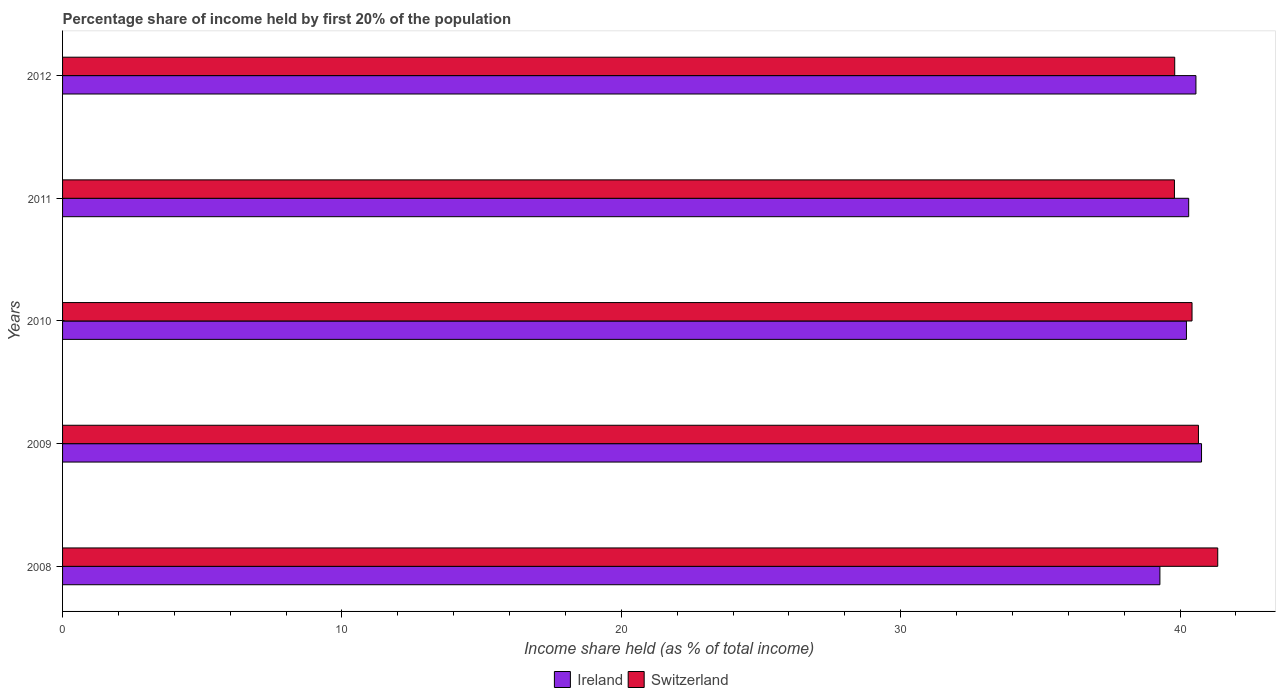How many groups of bars are there?
Provide a short and direct response. 5. Are the number of bars on each tick of the Y-axis equal?
Make the answer very short. Yes. How many bars are there on the 3rd tick from the top?
Provide a succinct answer. 2. How many bars are there on the 2nd tick from the bottom?
Your response must be concise. 2. What is the label of the 2nd group of bars from the top?
Provide a short and direct response. 2011. In how many cases, is the number of bars for a given year not equal to the number of legend labels?
Offer a very short reply. 0. What is the share of income held by first 20% of the population in Switzerland in 2012?
Keep it short and to the point. 39.81. Across all years, what is the maximum share of income held by first 20% of the population in Ireland?
Your answer should be very brief. 40.77. Across all years, what is the minimum share of income held by first 20% of the population in Ireland?
Offer a very short reply. 39.28. What is the total share of income held by first 20% of the population in Switzerland in the graph?
Your answer should be compact. 202.05. What is the difference between the share of income held by first 20% of the population in Switzerland in 2010 and that in 2012?
Offer a terse response. 0.62. What is the average share of income held by first 20% of the population in Ireland per year?
Provide a short and direct response. 40.23. In the year 2010, what is the difference between the share of income held by first 20% of the population in Switzerland and share of income held by first 20% of the population in Ireland?
Ensure brevity in your answer.  0.2. In how many years, is the share of income held by first 20% of the population in Ireland greater than 26 %?
Your answer should be very brief. 5. What is the ratio of the share of income held by first 20% of the population in Switzerland in 2008 to that in 2011?
Your response must be concise. 1.04. Is the share of income held by first 20% of the population in Ireland in 2011 less than that in 2012?
Keep it short and to the point. Yes. Is the difference between the share of income held by first 20% of the population in Switzerland in 2008 and 2010 greater than the difference between the share of income held by first 20% of the population in Ireland in 2008 and 2010?
Offer a very short reply. Yes. What is the difference between the highest and the second highest share of income held by first 20% of the population in Ireland?
Provide a short and direct response. 0.2. What is the difference between the highest and the lowest share of income held by first 20% of the population in Switzerland?
Provide a succinct answer. 1.55. In how many years, is the share of income held by first 20% of the population in Ireland greater than the average share of income held by first 20% of the population in Ireland taken over all years?
Offer a very short reply. 3. What does the 2nd bar from the top in 2011 represents?
Offer a very short reply. Ireland. What does the 1st bar from the bottom in 2012 represents?
Ensure brevity in your answer.  Ireland. What is the difference between two consecutive major ticks on the X-axis?
Give a very brief answer. 10. Are the values on the major ticks of X-axis written in scientific E-notation?
Your response must be concise. No. Does the graph contain grids?
Ensure brevity in your answer.  No. How many legend labels are there?
Offer a terse response. 2. How are the legend labels stacked?
Your response must be concise. Horizontal. What is the title of the graph?
Your answer should be compact. Percentage share of income held by first 20% of the population. What is the label or title of the X-axis?
Your response must be concise. Income share held (as % of total income). What is the label or title of the Y-axis?
Provide a succinct answer. Years. What is the Income share held (as % of total income) in Ireland in 2008?
Your answer should be compact. 39.28. What is the Income share held (as % of total income) in Switzerland in 2008?
Provide a succinct answer. 41.35. What is the Income share held (as % of total income) in Ireland in 2009?
Your answer should be compact. 40.77. What is the Income share held (as % of total income) of Switzerland in 2009?
Provide a short and direct response. 40.66. What is the Income share held (as % of total income) of Ireland in 2010?
Your answer should be very brief. 40.23. What is the Income share held (as % of total income) in Switzerland in 2010?
Provide a succinct answer. 40.43. What is the Income share held (as % of total income) in Ireland in 2011?
Make the answer very short. 40.31. What is the Income share held (as % of total income) of Switzerland in 2011?
Your response must be concise. 39.8. What is the Income share held (as % of total income) of Ireland in 2012?
Ensure brevity in your answer.  40.57. What is the Income share held (as % of total income) of Switzerland in 2012?
Offer a very short reply. 39.81. Across all years, what is the maximum Income share held (as % of total income) of Ireland?
Offer a very short reply. 40.77. Across all years, what is the maximum Income share held (as % of total income) in Switzerland?
Your answer should be very brief. 41.35. Across all years, what is the minimum Income share held (as % of total income) in Ireland?
Provide a short and direct response. 39.28. Across all years, what is the minimum Income share held (as % of total income) in Switzerland?
Offer a very short reply. 39.8. What is the total Income share held (as % of total income) in Ireland in the graph?
Your answer should be compact. 201.16. What is the total Income share held (as % of total income) of Switzerland in the graph?
Provide a short and direct response. 202.05. What is the difference between the Income share held (as % of total income) in Ireland in 2008 and that in 2009?
Keep it short and to the point. -1.49. What is the difference between the Income share held (as % of total income) in Switzerland in 2008 and that in 2009?
Provide a succinct answer. 0.69. What is the difference between the Income share held (as % of total income) of Ireland in 2008 and that in 2010?
Your answer should be very brief. -0.95. What is the difference between the Income share held (as % of total income) of Switzerland in 2008 and that in 2010?
Keep it short and to the point. 0.92. What is the difference between the Income share held (as % of total income) in Ireland in 2008 and that in 2011?
Offer a terse response. -1.03. What is the difference between the Income share held (as % of total income) in Switzerland in 2008 and that in 2011?
Your response must be concise. 1.55. What is the difference between the Income share held (as % of total income) in Ireland in 2008 and that in 2012?
Offer a terse response. -1.29. What is the difference between the Income share held (as % of total income) in Switzerland in 2008 and that in 2012?
Offer a terse response. 1.54. What is the difference between the Income share held (as % of total income) in Ireland in 2009 and that in 2010?
Provide a succinct answer. 0.54. What is the difference between the Income share held (as % of total income) of Switzerland in 2009 and that in 2010?
Offer a very short reply. 0.23. What is the difference between the Income share held (as % of total income) in Ireland in 2009 and that in 2011?
Give a very brief answer. 0.46. What is the difference between the Income share held (as % of total income) in Switzerland in 2009 and that in 2011?
Give a very brief answer. 0.86. What is the difference between the Income share held (as % of total income) in Ireland in 2010 and that in 2011?
Offer a terse response. -0.08. What is the difference between the Income share held (as % of total income) in Switzerland in 2010 and that in 2011?
Give a very brief answer. 0.63. What is the difference between the Income share held (as % of total income) of Ireland in 2010 and that in 2012?
Ensure brevity in your answer.  -0.34. What is the difference between the Income share held (as % of total income) in Switzerland in 2010 and that in 2012?
Give a very brief answer. 0.62. What is the difference between the Income share held (as % of total income) of Ireland in 2011 and that in 2012?
Ensure brevity in your answer.  -0.26. What is the difference between the Income share held (as % of total income) of Switzerland in 2011 and that in 2012?
Your answer should be very brief. -0.01. What is the difference between the Income share held (as % of total income) in Ireland in 2008 and the Income share held (as % of total income) in Switzerland in 2009?
Make the answer very short. -1.38. What is the difference between the Income share held (as % of total income) of Ireland in 2008 and the Income share held (as % of total income) of Switzerland in 2010?
Keep it short and to the point. -1.15. What is the difference between the Income share held (as % of total income) in Ireland in 2008 and the Income share held (as % of total income) in Switzerland in 2011?
Offer a very short reply. -0.52. What is the difference between the Income share held (as % of total income) of Ireland in 2008 and the Income share held (as % of total income) of Switzerland in 2012?
Offer a terse response. -0.53. What is the difference between the Income share held (as % of total income) in Ireland in 2009 and the Income share held (as % of total income) in Switzerland in 2010?
Offer a terse response. 0.34. What is the difference between the Income share held (as % of total income) of Ireland in 2009 and the Income share held (as % of total income) of Switzerland in 2011?
Give a very brief answer. 0.97. What is the difference between the Income share held (as % of total income) of Ireland in 2010 and the Income share held (as % of total income) of Switzerland in 2011?
Provide a short and direct response. 0.43. What is the difference between the Income share held (as % of total income) of Ireland in 2010 and the Income share held (as % of total income) of Switzerland in 2012?
Your answer should be compact. 0.42. What is the difference between the Income share held (as % of total income) in Ireland in 2011 and the Income share held (as % of total income) in Switzerland in 2012?
Your answer should be very brief. 0.5. What is the average Income share held (as % of total income) in Ireland per year?
Provide a short and direct response. 40.23. What is the average Income share held (as % of total income) in Switzerland per year?
Offer a very short reply. 40.41. In the year 2008, what is the difference between the Income share held (as % of total income) of Ireland and Income share held (as % of total income) of Switzerland?
Give a very brief answer. -2.07. In the year 2009, what is the difference between the Income share held (as % of total income) of Ireland and Income share held (as % of total income) of Switzerland?
Provide a succinct answer. 0.11. In the year 2011, what is the difference between the Income share held (as % of total income) in Ireland and Income share held (as % of total income) in Switzerland?
Offer a very short reply. 0.51. In the year 2012, what is the difference between the Income share held (as % of total income) of Ireland and Income share held (as % of total income) of Switzerland?
Your answer should be compact. 0.76. What is the ratio of the Income share held (as % of total income) of Ireland in 2008 to that in 2009?
Keep it short and to the point. 0.96. What is the ratio of the Income share held (as % of total income) in Ireland in 2008 to that in 2010?
Provide a short and direct response. 0.98. What is the ratio of the Income share held (as % of total income) of Switzerland in 2008 to that in 2010?
Make the answer very short. 1.02. What is the ratio of the Income share held (as % of total income) of Ireland in 2008 to that in 2011?
Give a very brief answer. 0.97. What is the ratio of the Income share held (as % of total income) in Switzerland in 2008 to that in 2011?
Your answer should be very brief. 1.04. What is the ratio of the Income share held (as % of total income) of Ireland in 2008 to that in 2012?
Ensure brevity in your answer.  0.97. What is the ratio of the Income share held (as % of total income) in Switzerland in 2008 to that in 2012?
Your answer should be compact. 1.04. What is the ratio of the Income share held (as % of total income) of Ireland in 2009 to that in 2010?
Make the answer very short. 1.01. What is the ratio of the Income share held (as % of total income) of Ireland in 2009 to that in 2011?
Give a very brief answer. 1.01. What is the ratio of the Income share held (as % of total income) of Switzerland in 2009 to that in 2011?
Provide a succinct answer. 1.02. What is the ratio of the Income share held (as % of total income) of Switzerland in 2009 to that in 2012?
Make the answer very short. 1.02. What is the ratio of the Income share held (as % of total income) in Switzerland in 2010 to that in 2011?
Provide a short and direct response. 1.02. What is the ratio of the Income share held (as % of total income) of Switzerland in 2010 to that in 2012?
Provide a succinct answer. 1.02. What is the ratio of the Income share held (as % of total income) in Switzerland in 2011 to that in 2012?
Make the answer very short. 1. What is the difference between the highest and the second highest Income share held (as % of total income) in Ireland?
Provide a succinct answer. 0.2. What is the difference between the highest and the second highest Income share held (as % of total income) of Switzerland?
Offer a terse response. 0.69. What is the difference between the highest and the lowest Income share held (as % of total income) of Ireland?
Offer a terse response. 1.49. What is the difference between the highest and the lowest Income share held (as % of total income) of Switzerland?
Give a very brief answer. 1.55. 